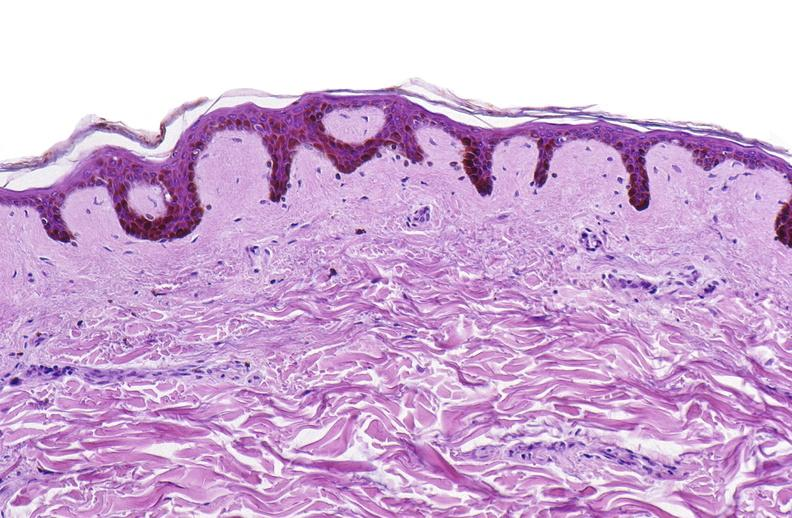where is this?
Answer the question using a single word or phrase. Skin 